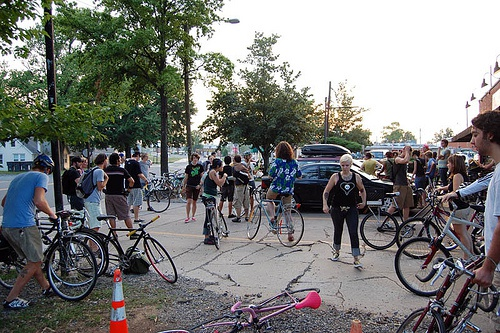Describe the objects in this image and their specific colors. I can see people in black, gray, darkgray, and maroon tones, people in black, blue, darkblue, and gray tones, bicycle in black, gray, darkgray, and navy tones, bicycle in black, gray, darkgray, and maroon tones, and people in black, gray, and darkgray tones in this image. 